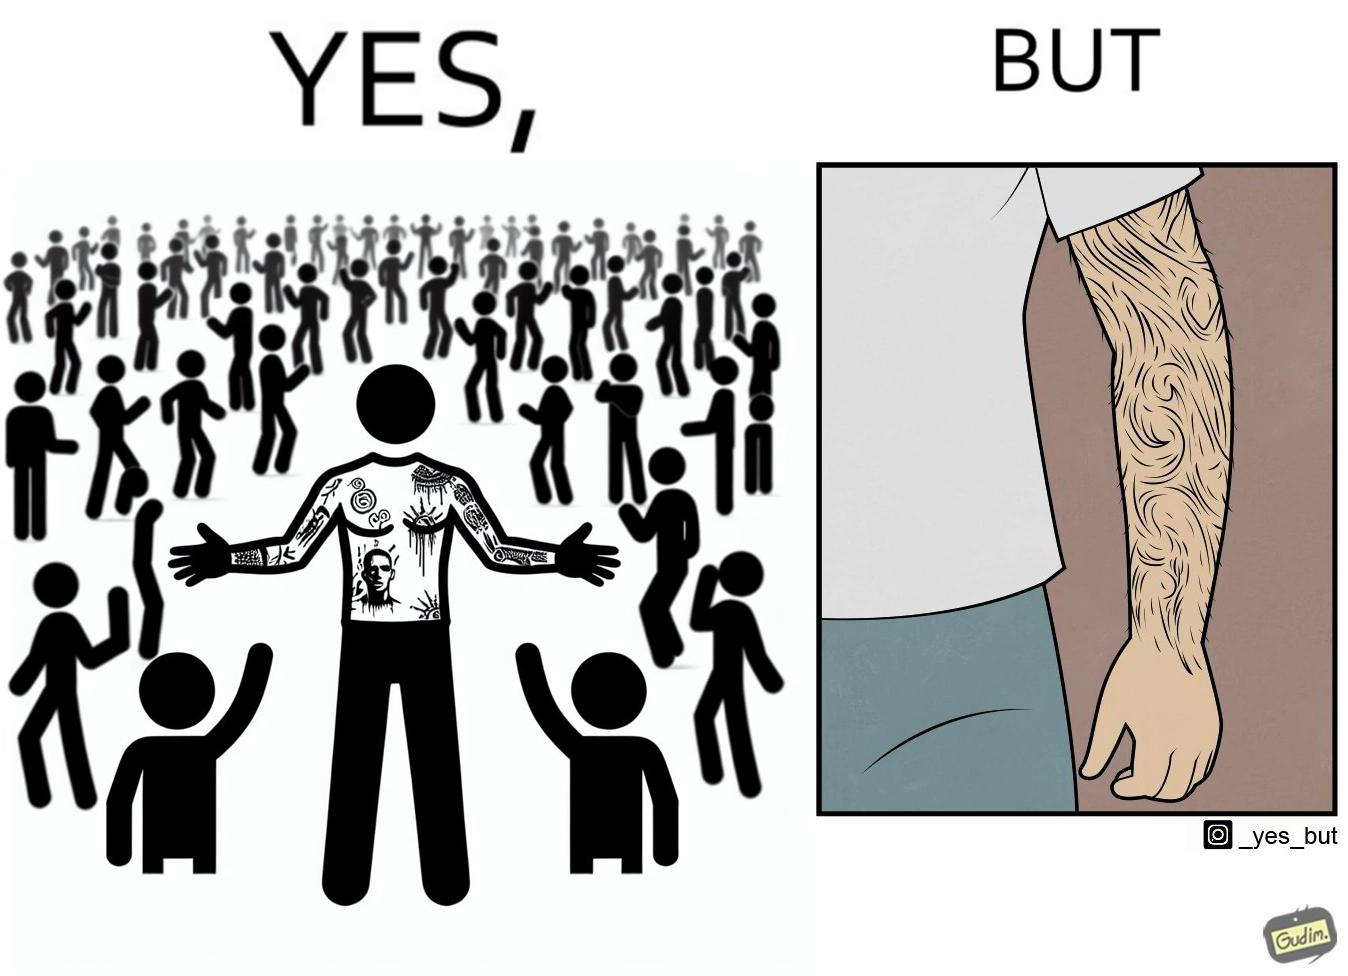Why is this image considered satirical? The image is funny because while from the distance it seems that the man has big tattoos on both of his arms upon a closer look at the arms it turns out there is no tattoo and what seemed to be tattoos are just hairs on his arm. 